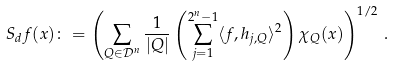Convert formula to latex. <formula><loc_0><loc_0><loc_500><loc_500>S _ { d } f ( x ) \colon = \left ( \sum _ { Q \in \mathcal { D } ^ { n } } \frac { 1 } { | Q | } \left ( \sum _ { j = 1 } ^ { 2 ^ { n } - 1 } \langle f , h _ { j , Q } \rangle ^ { 2 } \right ) \chi _ { Q } ( x ) \right ) ^ { 1 / 2 } \, .</formula> 